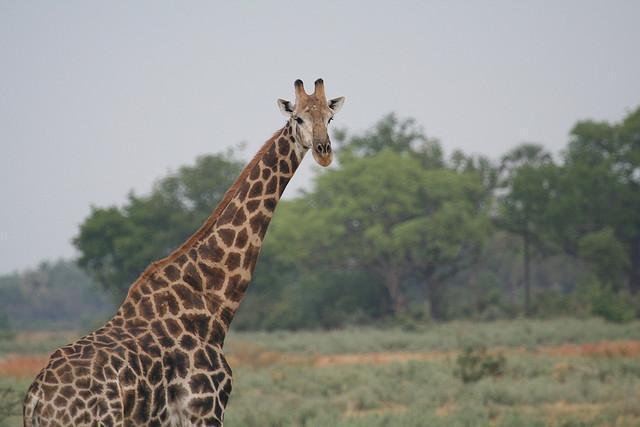How many giraffe's are in the picture?
Give a very brief answer. 1. How many giraffes are in the image?
Give a very brief answer. 1. How many giraffes are there?
Give a very brief answer. 1. How many giraffes are pictured?
Give a very brief answer. 1. How many giraffes?
Give a very brief answer. 1. How many animals are there?
Give a very brief answer. 1. 